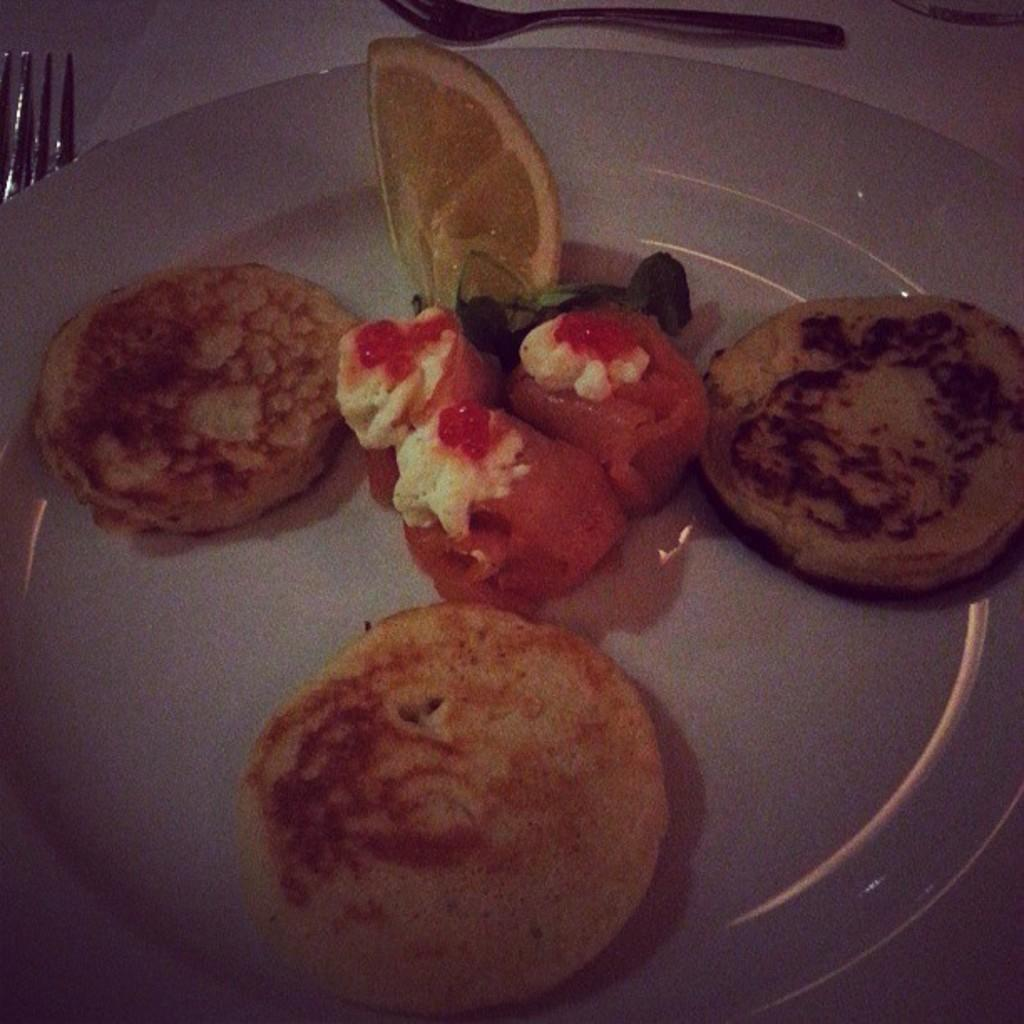What is on the plate that is visible in the image? There is food on a plate in the image. What utensils are present on the surface in the image? There are forks on the surface in the image. What song is being sung by the visitor in the image? There is no visitor or song present in the image. How does the wash cycle affect the food on the plate in the image? There is no mention of a wash cycle or any washing activity in the image; it only shows food on a plate and forks on a surface. 